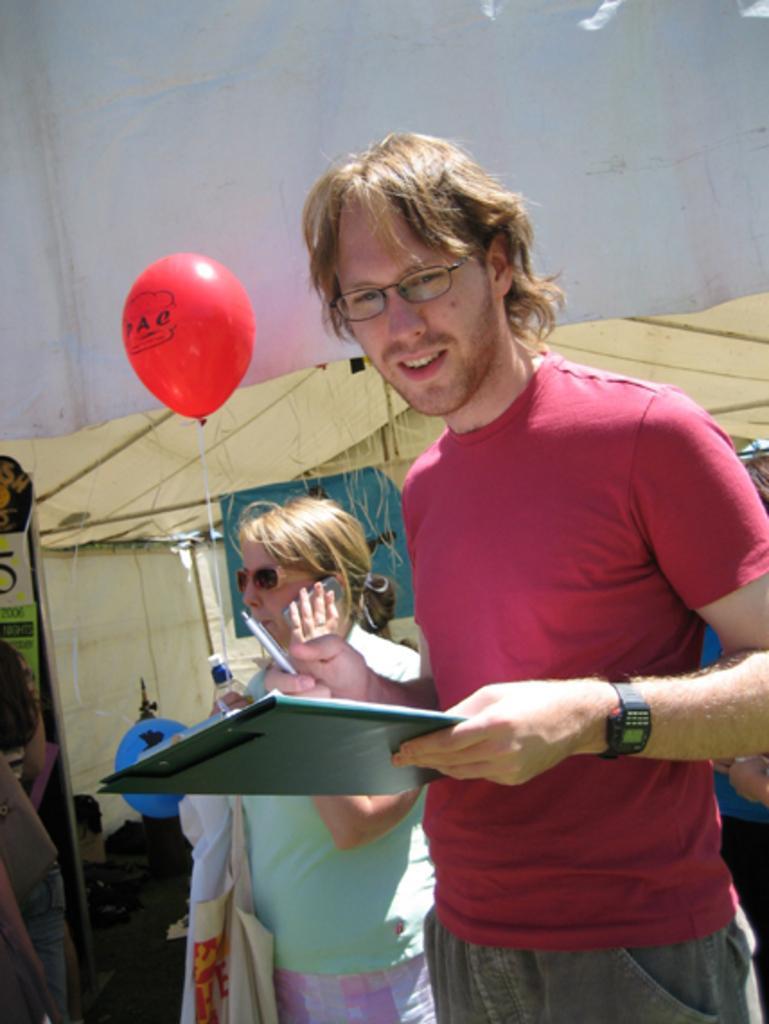Could you give a brief overview of what you see in this image? In this image I can see there is a person standing and holding a pen and a pad. And the other person talking on the phone. There is a shed, Balloon and an object. And at the background there is a sky. 